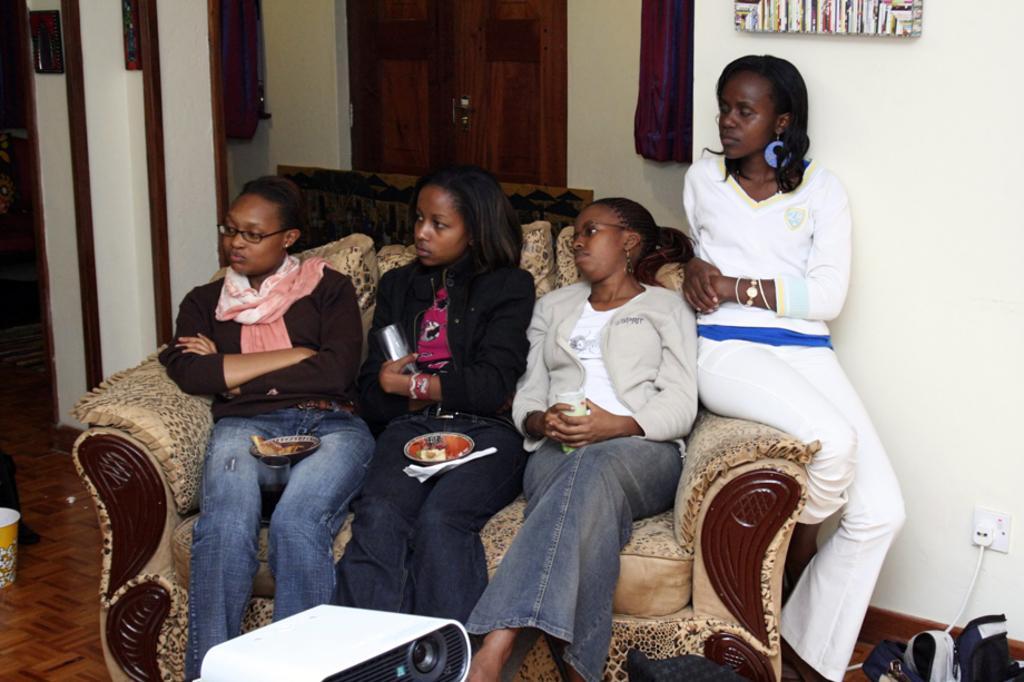Can you describe this image briefly? In this image we can see a few persons sitting on the sofa, among them some are holding the objects, in the background, we can the wall with some objects and a door, on the floor there we can see some other objects. 